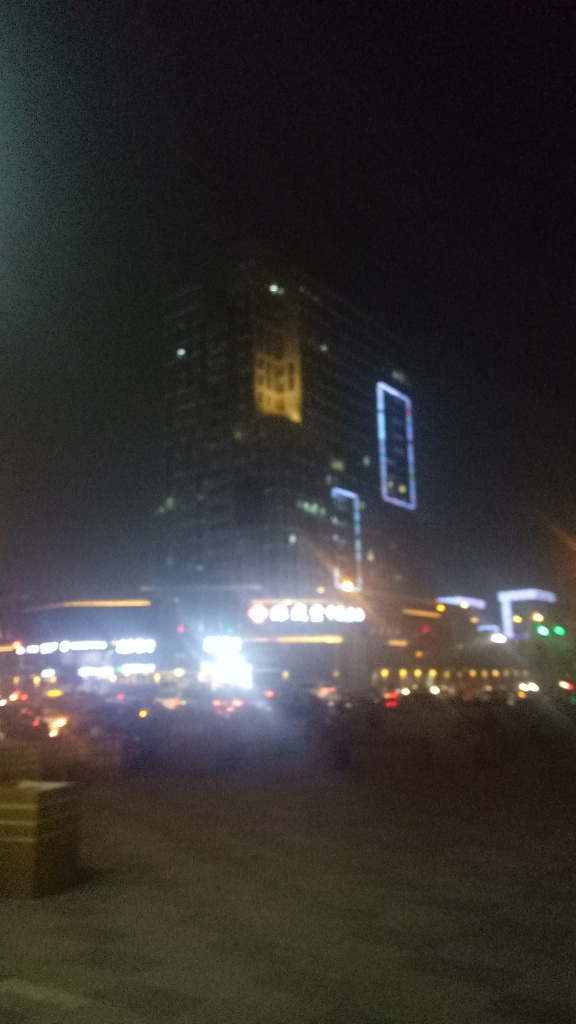Are there any features in this image that indicate the location or setting? Although the image is blurry, the high-rise buildings with illuminated facade accents and signage suggest a commercial or downtown area of a modern city. The neon lights and what look like lit billboards indicate a space that is possibly a hub for nightlife or business. 